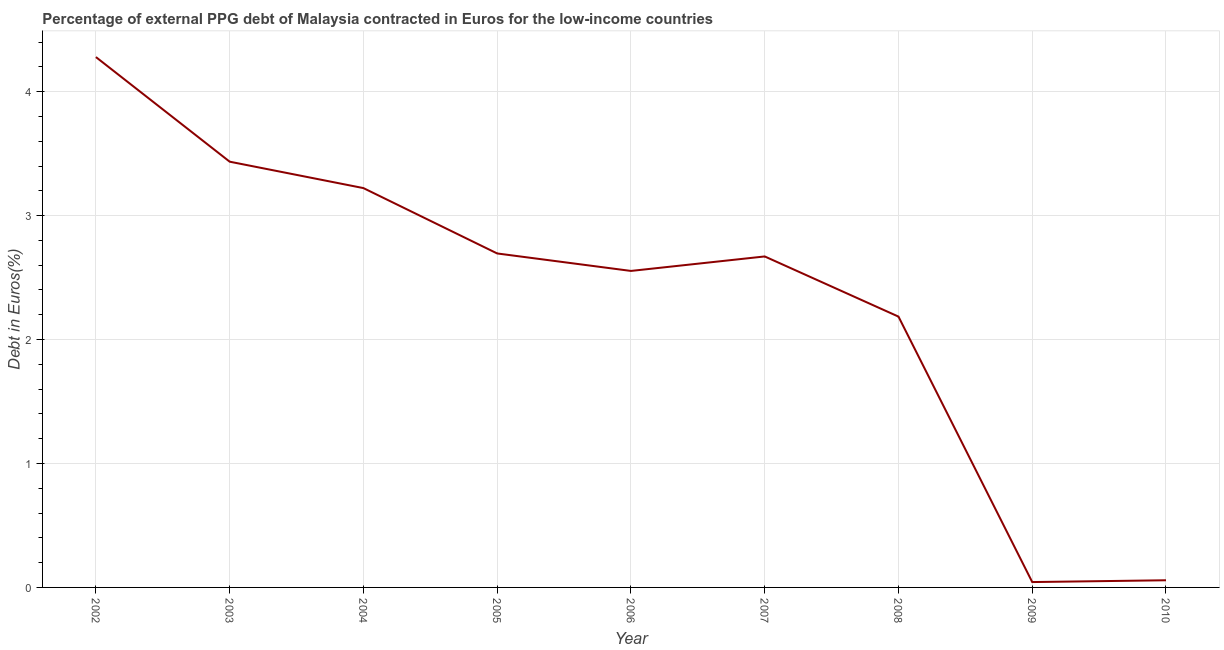What is the currency composition of ppg debt in 2009?
Keep it short and to the point. 0.04. Across all years, what is the maximum currency composition of ppg debt?
Keep it short and to the point. 4.28. Across all years, what is the minimum currency composition of ppg debt?
Offer a very short reply. 0.04. In which year was the currency composition of ppg debt maximum?
Give a very brief answer. 2002. What is the sum of the currency composition of ppg debt?
Your answer should be very brief. 21.14. What is the difference between the currency composition of ppg debt in 2006 and 2010?
Provide a short and direct response. 2.5. What is the average currency composition of ppg debt per year?
Make the answer very short. 2.35. What is the median currency composition of ppg debt?
Your answer should be compact. 2.67. In how many years, is the currency composition of ppg debt greater than 2.4 %?
Give a very brief answer. 6. What is the ratio of the currency composition of ppg debt in 2004 to that in 2009?
Provide a short and direct response. 74.42. Is the currency composition of ppg debt in 2007 less than that in 2008?
Ensure brevity in your answer.  No. Is the difference between the currency composition of ppg debt in 2005 and 2010 greater than the difference between any two years?
Provide a succinct answer. No. What is the difference between the highest and the second highest currency composition of ppg debt?
Provide a succinct answer. 0.84. Is the sum of the currency composition of ppg debt in 2007 and 2009 greater than the maximum currency composition of ppg debt across all years?
Offer a very short reply. No. What is the difference between the highest and the lowest currency composition of ppg debt?
Give a very brief answer. 4.24. Does the currency composition of ppg debt monotonically increase over the years?
Offer a very short reply. No. What is the difference between two consecutive major ticks on the Y-axis?
Make the answer very short. 1. Does the graph contain any zero values?
Keep it short and to the point. No. What is the title of the graph?
Provide a succinct answer. Percentage of external PPG debt of Malaysia contracted in Euros for the low-income countries. What is the label or title of the Y-axis?
Provide a short and direct response. Debt in Euros(%). What is the Debt in Euros(%) of 2002?
Offer a very short reply. 4.28. What is the Debt in Euros(%) in 2003?
Ensure brevity in your answer.  3.44. What is the Debt in Euros(%) of 2004?
Offer a very short reply. 3.22. What is the Debt in Euros(%) in 2005?
Provide a succinct answer. 2.69. What is the Debt in Euros(%) of 2006?
Offer a very short reply. 2.55. What is the Debt in Euros(%) of 2007?
Provide a short and direct response. 2.67. What is the Debt in Euros(%) in 2008?
Give a very brief answer. 2.19. What is the Debt in Euros(%) of 2009?
Provide a succinct answer. 0.04. What is the Debt in Euros(%) of 2010?
Ensure brevity in your answer.  0.06. What is the difference between the Debt in Euros(%) in 2002 and 2003?
Your answer should be compact. 0.84. What is the difference between the Debt in Euros(%) in 2002 and 2004?
Offer a terse response. 1.06. What is the difference between the Debt in Euros(%) in 2002 and 2005?
Provide a succinct answer. 1.58. What is the difference between the Debt in Euros(%) in 2002 and 2006?
Your answer should be compact. 1.73. What is the difference between the Debt in Euros(%) in 2002 and 2007?
Provide a succinct answer. 1.61. What is the difference between the Debt in Euros(%) in 2002 and 2008?
Your answer should be compact. 2.09. What is the difference between the Debt in Euros(%) in 2002 and 2009?
Your answer should be very brief. 4.24. What is the difference between the Debt in Euros(%) in 2002 and 2010?
Give a very brief answer. 4.22. What is the difference between the Debt in Euros(%) in 2003 and 2004?
Provide a short and direct response. 0.21. What is the difference between the Debt in Euros(%) in 2003 and 2005?
Provide a succinct answer. 0.74. What is the difference between the Debt in Euros(%) in 2003 and 2006?
Your answer should be very brief. 0.88. What is the difference between the Debt in Euros(%) in 2003 and 2007?
Keep it short and to the point. 0.76. What is the difference between the Debt in Euros(%) in 2003 and 2008?
Offer a terse response. 1.25. What is the difference between the Debt in Euros(%) in 2003 and 2009?
Ensure brevity in your answer.  3.39. What is the difference between the Debt in Euros(%) in 2003 and 2010?
Your answer should be very brief. 3.38. What is the difference between the Debt in Euros(%) in 2004 and 2005?
Offer a terse response. 0.53. What is the difference between the Debt in Euros(%) in 2004 and 2006?
Provide a succinct answer. 0.67. What is the difference between the Debt in Euros(%) in 2004 and 2007?
Your answer should be compact. 0.55. What is the difference between the Debt in Euros(%) in 2004 and 2008?
Your answer should be compact. 1.04. What is the difference between the Debt in Euros(%) in 2004 and 2009?
Keep it short and to the point. 3.18. What is the difference between the Debt in Euros(%) in 2004 and 2010?
Your answer should be compact. 3.16. What is the difference between the Debt in Euros(%) in 2005 and 2006?
Provide a short and direct response. 0.14. What is the difference between the Debt in Euros(%) in 2005 and 2007?
Keep it short and to the point. 0.02. What is the difference between the Debt in Euros(%) in 2005 and 2008?
Make the answer very short. 0.51. What is the difference between the Debt in Euros(%) in 2005 and 2009?
Offer a terse response. 2.65. What is the difference between the Debt in Euros(%) in 2005 and 2010?
Your response must be concise. 2.64. What is the difference between the Debt in Euros(%) in 2006 and 2007?
Make the answer very short. -0.12. What is the difference between the Debt in Euros(%) in 2006 and 2008?
Give a very brief answer. 0.37. What is the difference between the Debt in Euros(%) in 2006 and 2009?
Your answer should be compact. 2.51. What is the difference between the Debt in Euros(%) in 2006 and 2010?
Give a very brief answer. 2.5. What is the difference between the Debt in Euros(%) in 2007 and 2008?
Your answer should be very brief. 0.49. What is the difference between the Debt in Euros(%) in 2007 and 2009?
Your answer should be compact. 2.63. What is the difference between the Debt in Euros(%) in 2007 and 2010?
Give a very brief answer. 2.61. What is the difference between the Debt in Euros(%) in 2008 and 2009?
Provide a succinct answer. 2.14. What is the difference between the Debt in Euros(%) in 2008 and 2010?
Provide a succinct answer. 2.13. What is the difference between the Debt in Euros(%) in 2009 and 2010?
Ensure brevity in your answer.  -0.01. What is the ratio of the Debt in Euros(%) in 2002 to that in 2003?
Give a very brief answer. 1.25. What is the ratio of the Debt in Euros(%) in 2002 to that in 2004?
Offer a terse response. 1.33. What is the ratio of the Debt in Euros(%) in 2002 to that in 2005?
Your answer should be very brief. 1.59. What is the ratio of the Debt in Euros(%) in 2002 to that in 2006?
Make the answer very short. 1.68. What is the ratio of the Debt in Euros(%) in 2002 to that in 2007?
Your answer should be compact. 1.6. What is the ratio of the Debt in Euros(%) in 2002 to that in 2008?
Give a very brief answer. 1.96. What is the ratio of the Debt in Euros(%) in 2002 to that in 2009?
Provide a short and direct response. 98.83. What is the ratio of the Debt in Euros(%) in 2002 to that in 2010?
Make the answer very short. 74.04. What is the ratio of the Debt in Euros(%) in 2003 to that in 2004?
Provide a short and direct response. 1.07. What is the ratio of the Debt in Euros(%) in 2003 to that in 2005?
Your answer should be very brief. 1.27. What is the ratio of the Debt in Euros(%) in 2003 to that in 2006?
Offer a terse response. 1.34. What is the ratio of the Debt in Euros(%) in 2003 to that in 2007?
Your answer should be compact. 1.29. What is the ratio of the Debt in Euros(%) in 2003 to that in 2008?
Provide a short and direct response. 1.57. What is the ratio of the Debt in Euros(%) in 2003 to that in 2009?
Provide a succinct answer. 79.34. What is the ratio of the Debt in Euros(%) in 2003 to that in 2010?
Give a very brief answer. 59.43. What is the ratio of the Debt in Euros(%) in 2004 to that in 2005?
Ensure brevity in your answer.  1.2. What is the ratio of the Debt in Euros(%) in 2004 to that in 2006?
Give a very brief answer. 1.26. What is the ratio of the Debt in Euros(%) in 2004 to that in 2007?
Provide a succinct answer. 1.21. What is the ratio of the Debt in Euros(%) in 2004 to that in 2008?
Your answer should be compact. 1.47. What is the ratio of the Debt in Euros(%) in 2004 to that in 2009?
Your answer should be compact. 74.42. What is the ratio of the Debt in Euros(%) in 2004 to that in 2010?
Your answer should be compact. 55.75. What is the ratio of the Debt in Euros(%) in 2005 to that in 2006?
Offer a very short reply. 1.05. What is the ratio of the Debt in Euros(%) in 2005 to that in 2007?
Provide a short and direct response. 1.01. What is the ratio of the Debt in Euros(%) in 2005 to that in 2008?
Give a very brief answer. 1.23. What is the ratio of the Debt in Euros(%) in 2005 to that in 2009?
Provide a succinct answer. 62.24. What is the ratio of the Debt in Euros(%) in 2005 to that in 2010?
Offer a very short reply. 46.62. What is the ratio of the Debt in Euros(%) in 2006 to that in 2007?
Your answer should be compact. 0.96. What is the ratio of the Debt in Euros(%) in 2006 to that in 2008?
Make the answer very short. 1.17. What is the ratio of the Debt in Euros(%) in 2006 to that in 2009?
Your answer should be very brief. 58.98. What is the ratio of the Debt in Euros(%) in 2006 to that in 2010?
Offer a very short reply. 44.18. What is the ratio of the Debt in Euros(%) in 2007 to that in 2008?
Provide a short and direct response. 1.22. What is the ratio of the Debt in Euros(%) in 2007 to that in 2009?
Provide a succinct answer. 61.68. What is the ratio of the Debt in Euros(%) in 2007 to that in 2010?
Keep it short and to the point. 46.21. What is the ratio of the Debt in Euros(%) in 2008 to that in 2009?
Provide a succinct answer. 50.47. What is the ratio of the Debt in Euros(%) in 2008 to that in 2010?
Offer a terse response. 37.81. What is the ratio of the Debt in Euros(%) in 2009 to that in 2010?
Your response must be concise. 0.75. 